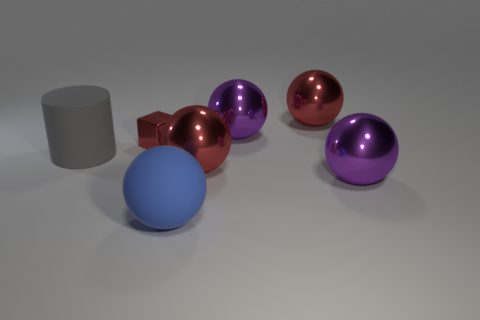Subtract all purple spheres. How many were subtracted if there are1purple spheres left? 1 Subtract all rubber balls. How many balls are left? 4 Subtract all cubes. How many objects are left? 6 Subtract 1 cylinders. How many cylinders are left? 0 Add 7 metallic cubes. How many metallic cubes are left? 8 Add 1 small shiny cubes. How many small shiny cubes exist? 2 Add 3 tiny cubes. How many objects exist? 10 Subtract all red spheres. How many spheres are left? 3 Subtract 0 brown cylinders. How many objects are left? 7 Subtract all red balls. Subtract all yellow blocks. How many balls are left? 3 